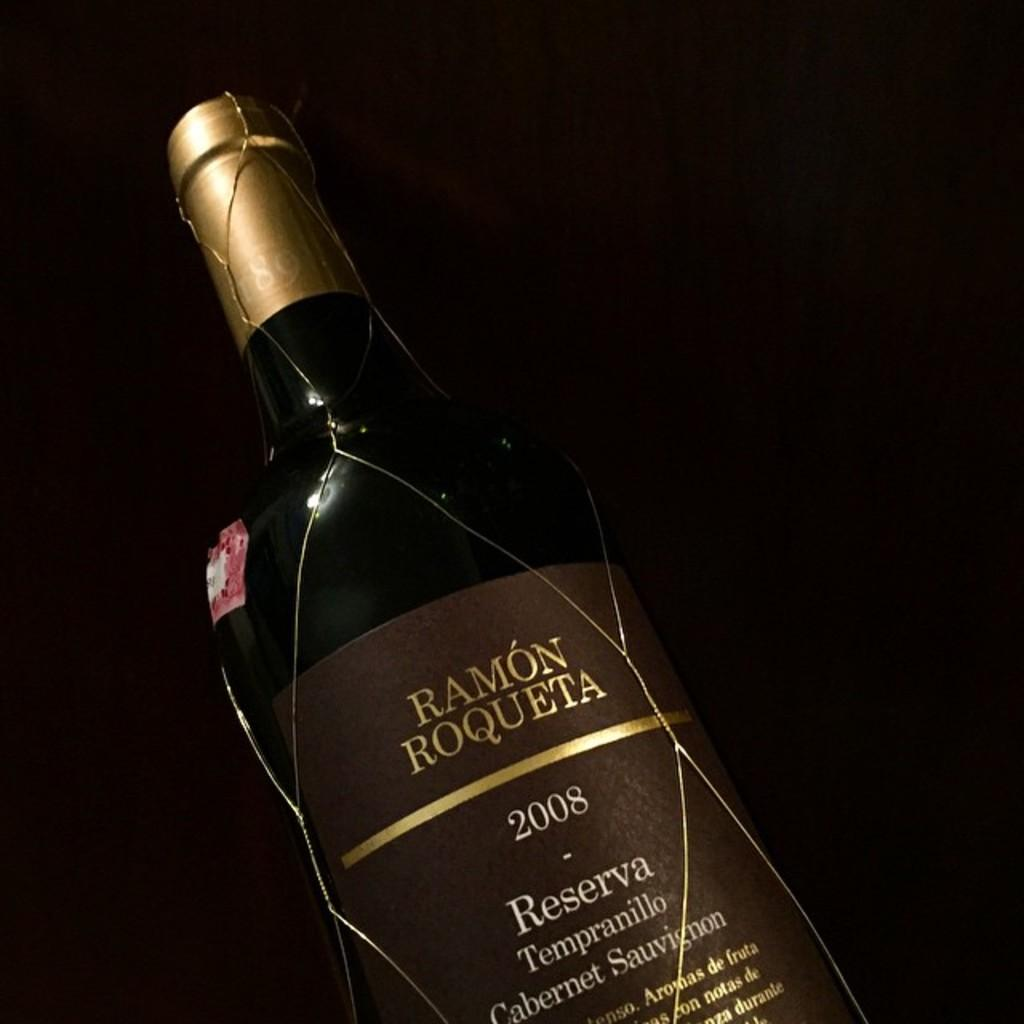<image>
Relay a brief, clear account of the picture shown. A 2008 bottle of Ramon Roqueta reserva all by itself. 